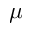Convert formula to latex. <formula><loc_0><loc_0><loc_500><loc_500>\mu</formula> 